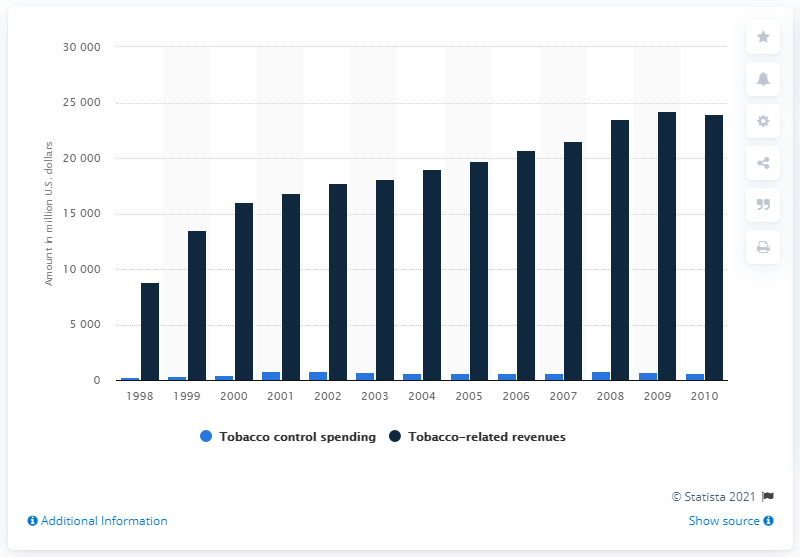Point out several critical features in this image. In 2002, the revenue generated through tobacco was approximately 17,775.9. 